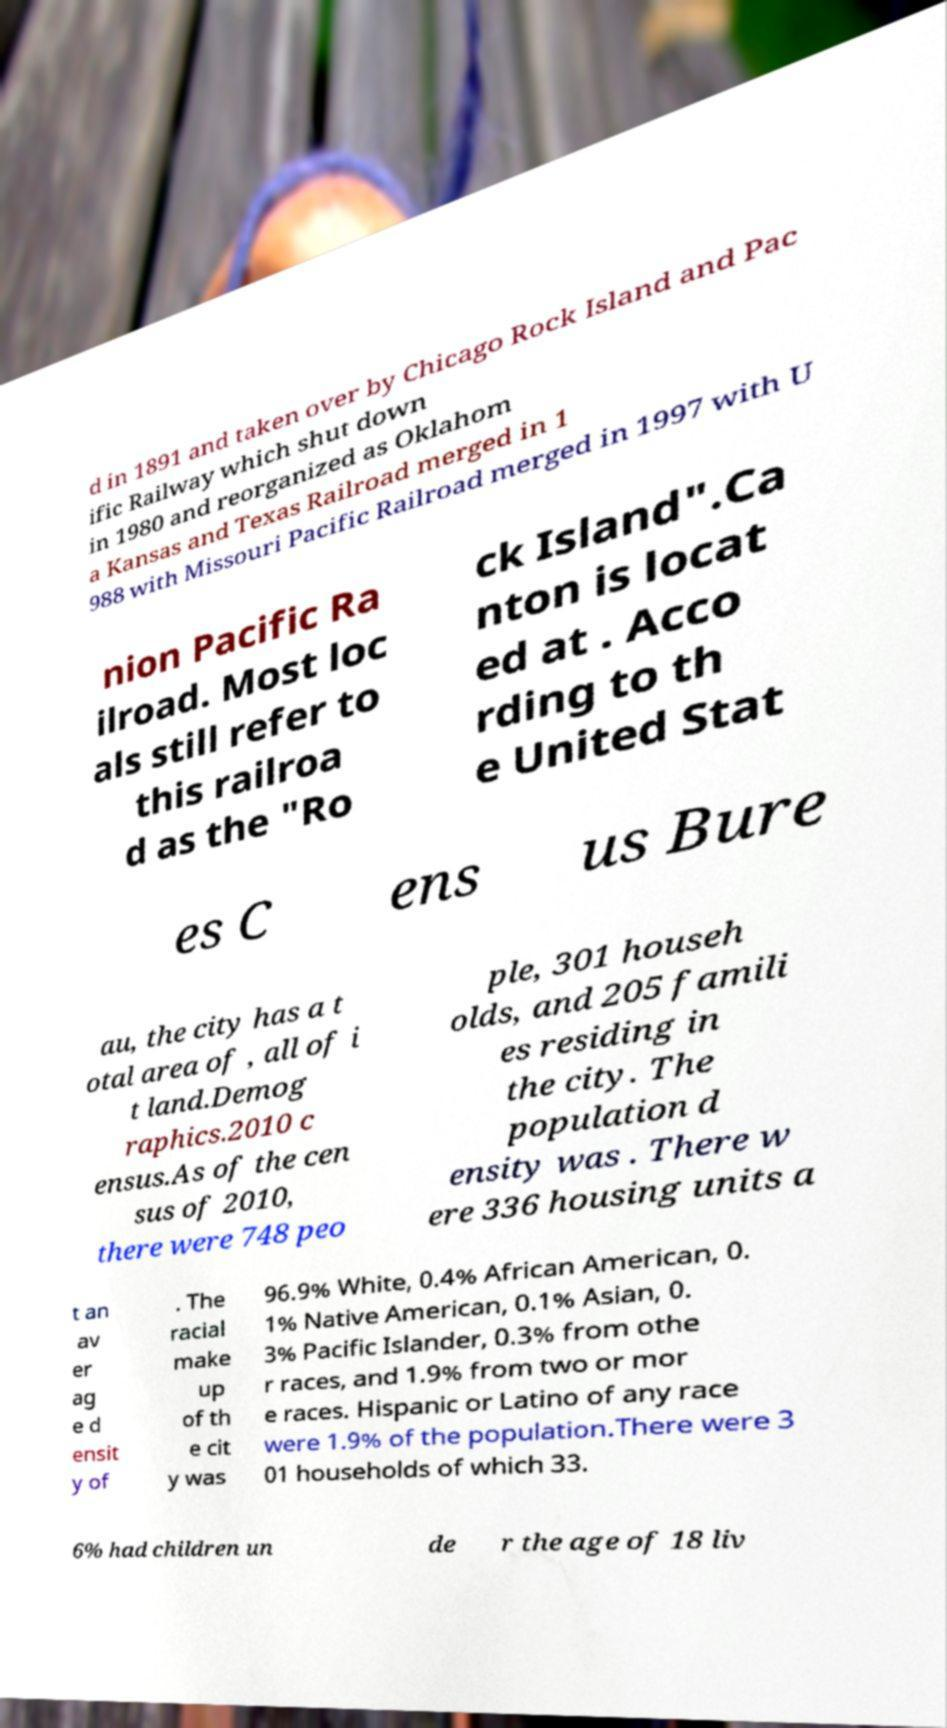There's text embedded in this image that I need extracted. Can you transcribe it verbatim? d in 1891 and taken over by Chicago Rock Island and Pac ific Railway which shut down in 1980 and reorganized as Oklahom a Kansas and Texas Railroad merged in 1 988 with Missouri Pacific Railroad merged in 1997 with U nion Pacific Ra ilroad. Most loc als still refer to this railroa d as the "Ro ck Island".Ca nton is locat ed at . Acco rding to th e United Stat es C ens us Bure au, the city has a t otal area of , all of i t land.Demog raphics.2010 c ensus.As of the cen sus of 2010, there were 748 peo ple, 301 househ olds, and 205 famili es residing in the city. The population d ensity was . There w ere 336 housing units a t an av er ag e d ensit y of . The racial make up of th e cit y was 96.9% White, 0.4% African American, 0. 1% Native American, 0.1% Asian, 0. 3% Pacific Islander, 0.3% from othe r races, and 1.9% from two or mor e races. Hispanic or Latino of any race were 1.9% of the population.There were 3 01 households of which 33. 6% had children un de r the age of 18 liv 